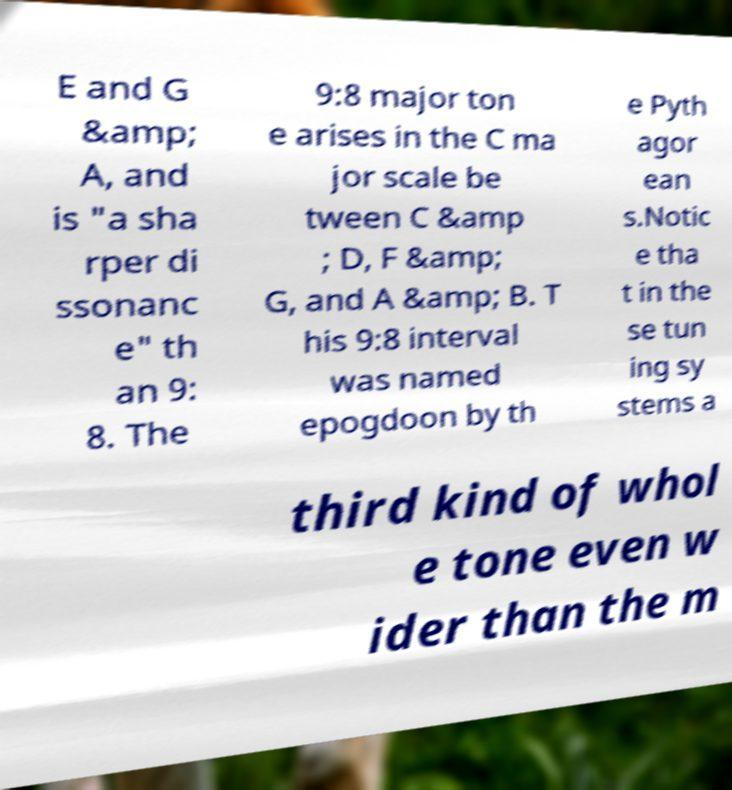What messages or text are displayed in this image? I need them in a readable, typed format. E and G &amp; A, and is "a sha rper di ssonanc e" th an 9: 8. The 9:8 major ton e arises in the C ma jor scale be tween C &amp ; D, F &amp; G, and A &amp; B. T his 9:8 interval was named epogdoon by th e Pyth agor ean s.Notic e tha t in the se tun ing sy stems a third kind of whol e tone even w ider than the m 